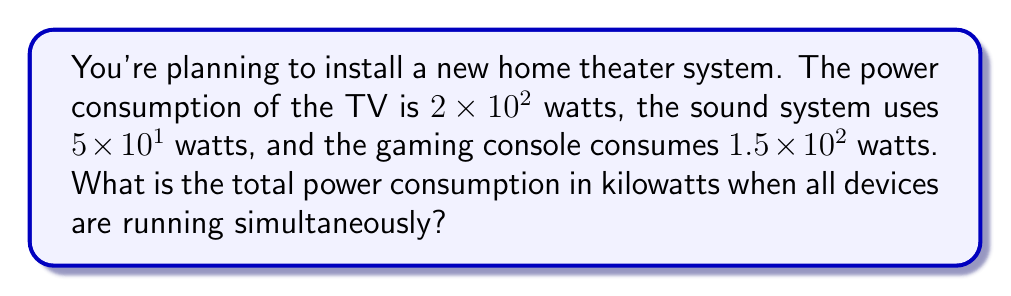Teach me how to tackle this problem. Let's approach this step-by-step:

1) First, let's convert all power consumptions to the same unit (watts):
   TV: $2 \times 10^2$ watts
   Sound system: $5 \times 10^1$ watts
   Gaming console: $1.5 \times 10^2$ watts

2) Now, let's add these values:
   Total watts = $2 \times 10^2 + 5 \times 10^1 + 1.5 \times 10^2$

3) Simplify:
   $2 \times 10^2 = 200$ watts
   $5 \times 10^1 = 50$ watts
   $1.5 \times 10^2 = 150$ watts

4) Add these values:
   Total watts = $200 + 50 + 150 = 400$ watts

5) Convert watts to kilowatts:
   $400$ watts = $400 \div 10^3 = 0.4$ kilowatts

6) Express in scientific notation:
   $0.4$ kilowatts = $4 \times 10^{-1}$ kilowatts
Answer: $4 \times 10^{-1}$ kW 